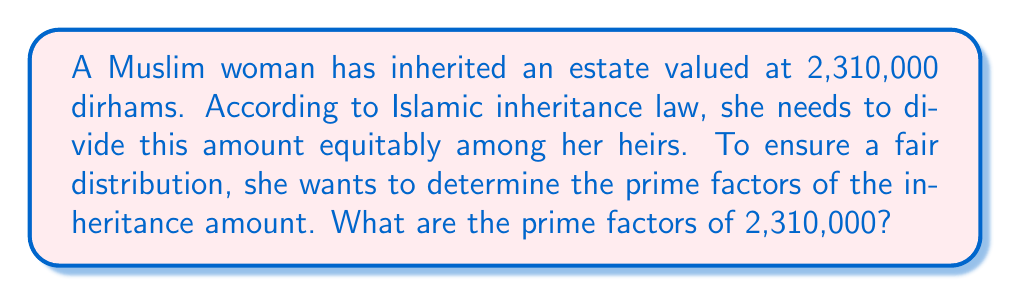Provide a solution to this math problem. To find the prime factors of 2,310,000, we'll use the process of prime factorization:

1) First, let's divide by 2 as many times as possible:
   $$2,310,000 = 2 \times 1,155,000$$
   $$1,155,000 = 2 \times 577,500$$
   $$577,500 = 2 \times 288,750$$
   $$288,750 = 2 \times 144,375$$
   $$144,375 = 2 \times 72,187.5$$

2) We can't divide by 2 anymore. The next prime number is 3:
   $$72,187.5 = 3 \times 24,062.5$$

3) We can divide by 3 again:
   $$24,062.5 = 3 \times 8,020.833...$$

4) Now, let's try 5:
   $$8,020.833... = 5 \times 1,604.166...$$

5) We can divide by 5 again:
   $$1,604.166... = 5 \times 320.833...$$

6) The next prime factor is 7:
   $$320.833... = 7 \times 45.833...$$

7) Finally, we can divide by 11:
   $$45.833... = 11 \times 4.166...$$

8) The last factor, 4.166..., is actually $\frac{25}{6}$, which can be further factored:
   $$\frac{25}{6} = \frac{5^2}{2 \times 3}$$

Therefore, the complete prime factorization is:

$$2,310,000 = 2^5 \times 3^2 \times 5^3 \times 7 \times 11$$
Answer: $2^5 \times 3^2 \times 5^3 \times 7 \times 11$ 